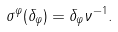Convert formula to latex. <formula><loc_0><loc_0><loc_500><loc_500>\sigma ^ { \varphi } ( \delta _ { \varphi } ) = \delta _ { \varphi } \nu ^ { - 1 } .</formula> 